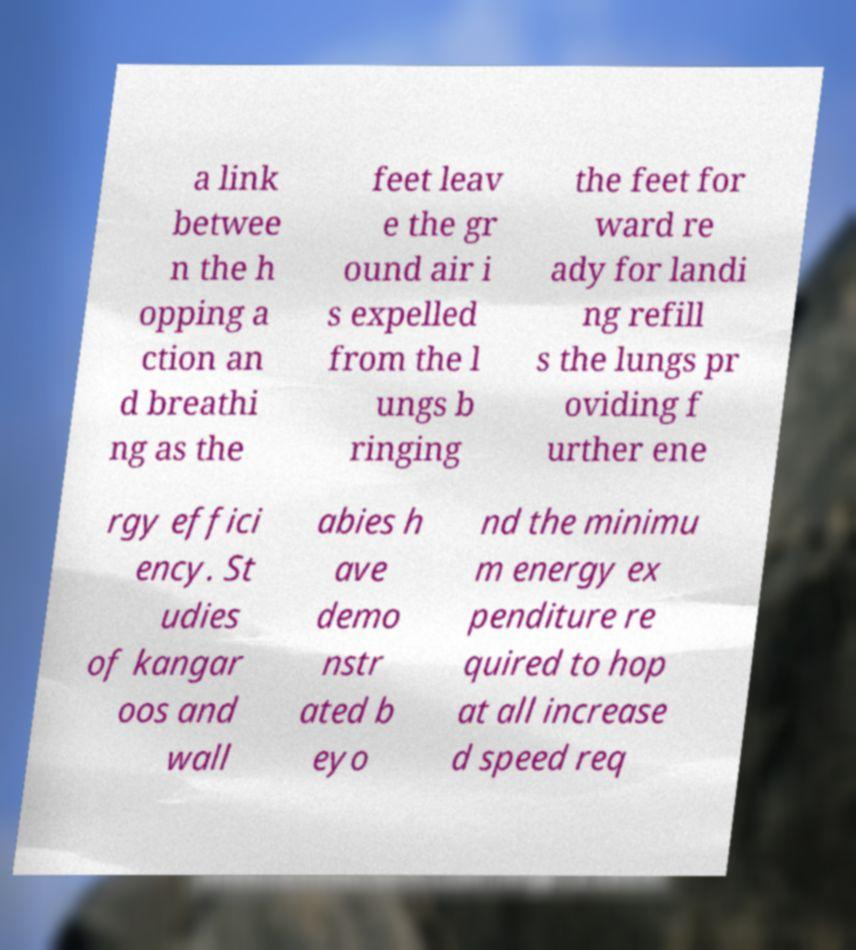Could you assist in decoding the text presented in this image and type it out clearly? a link betwee n the h opping a ction an d breathi ng as the feet leav e the gr ound air i s expelled from the l ungs b ringing the feet for ward re ady for landi ng refill s the lungs pr oviding f urther ene rgy effici ency. St udies of kangar oos and wall abies h ave demo nstr ated b eyo nd the minimu m energy ex penditure re quired to hop at all increase d speed req 